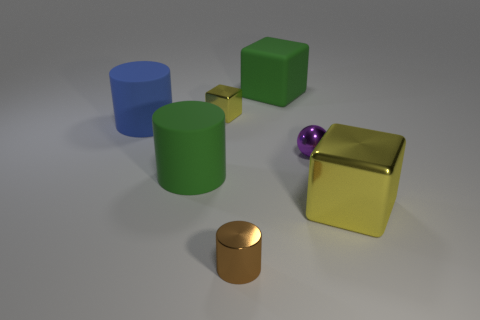Subtract all tiny metallic blocks. How many blocks are left? 2 Add 3 small balls. How many objects exist? 10 Subtract all green cubes. How many cubes are left? 2 Subtract all red spheres. How many yellow blocks are left? 2 Subtract all cylinders. How many objects are left? 4 Subtract all purple blocks. Subtract all green balls. How many blocks are left? 3 Subtract all big green matte objects. Subtract all green matte cubes. How many objects are left? 4 Add 5 big yellow cubes. How many big yellow cubes are left? 6 Add 1 small red cylinders. How many small red cylinders exist? 1 Subtract 0 yellow cylinders. How many objects are left? 7 